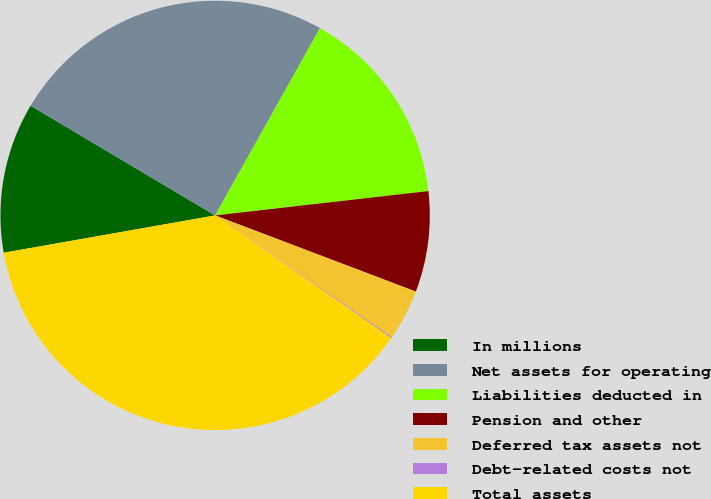<chart> <loc_0><loc_0><loc_500><loc_500><pie_chart><fcel>In millions<fcel>Net assets for operating<fcel>Liabilities deducted in<fcel>Pension and other<fcel>Deferred tax assets not<fcel>Debt-related costs not<fcel>Total assets<nl><fcel>11.32%<fcel>24.59%<fcel>15.07%<fcel>7.58%<fcel>3.83%<fcel>0.08%<fcel>37.54%<nl></chart> 